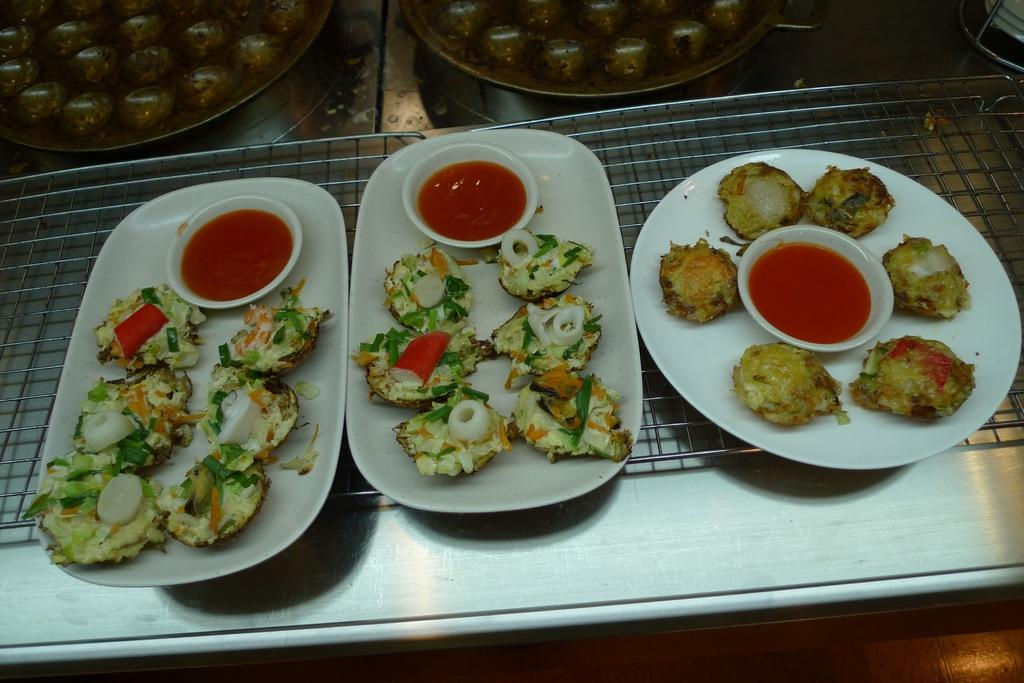How many plates of food items are visible in the image? There are three plates of food items in the image. What accompanies each plate of food? Each plate has a corresponding sauce cup. Where are the plates placed? The plates are placed on a grill. Are there any other plates visible in the image? Yes, there are two additional plates visible in the background of the image. How many sisters are present in the image? There is no mention of any people, let alone sisters, in the image. 